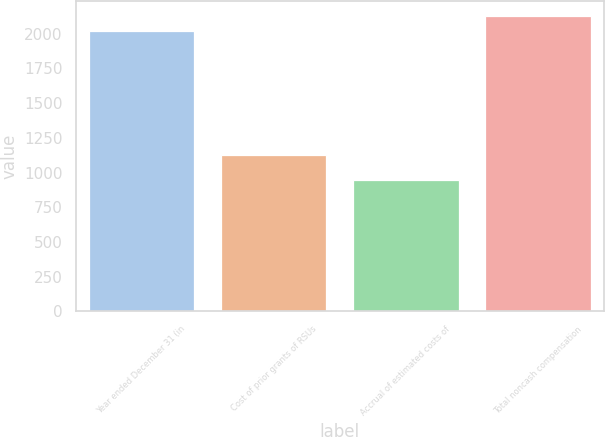<chart> <loc_0><loc_0><loc_500><loc_500><bar_chart><fcel>Year ended December 31 (in<fcel>Cost of prior grants of RSUs<fcel>Accrual of estimated costs of<fcel>Total noncash compensation<nl><fcel>2017<fcel>1125<fcel>945<fcel>2129.5<nl></chart> 